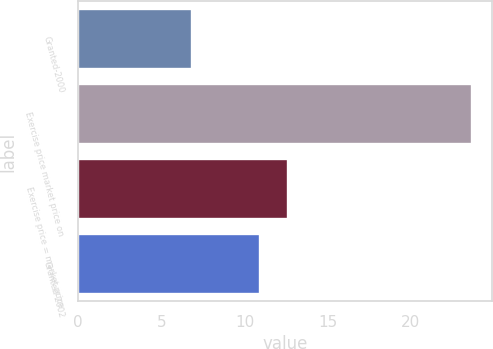<chart> <loc_0><loc_0><loc_500><loc_500><bar_chart><fcel>Granted-2000<fcel>Exercise price market price on<fcel>Exercise price = market price<fcel>Granted-2002<nl><fcel>6.86<fcel>23.69<fcel>12.59<fcel>10.91<nl></chart> 